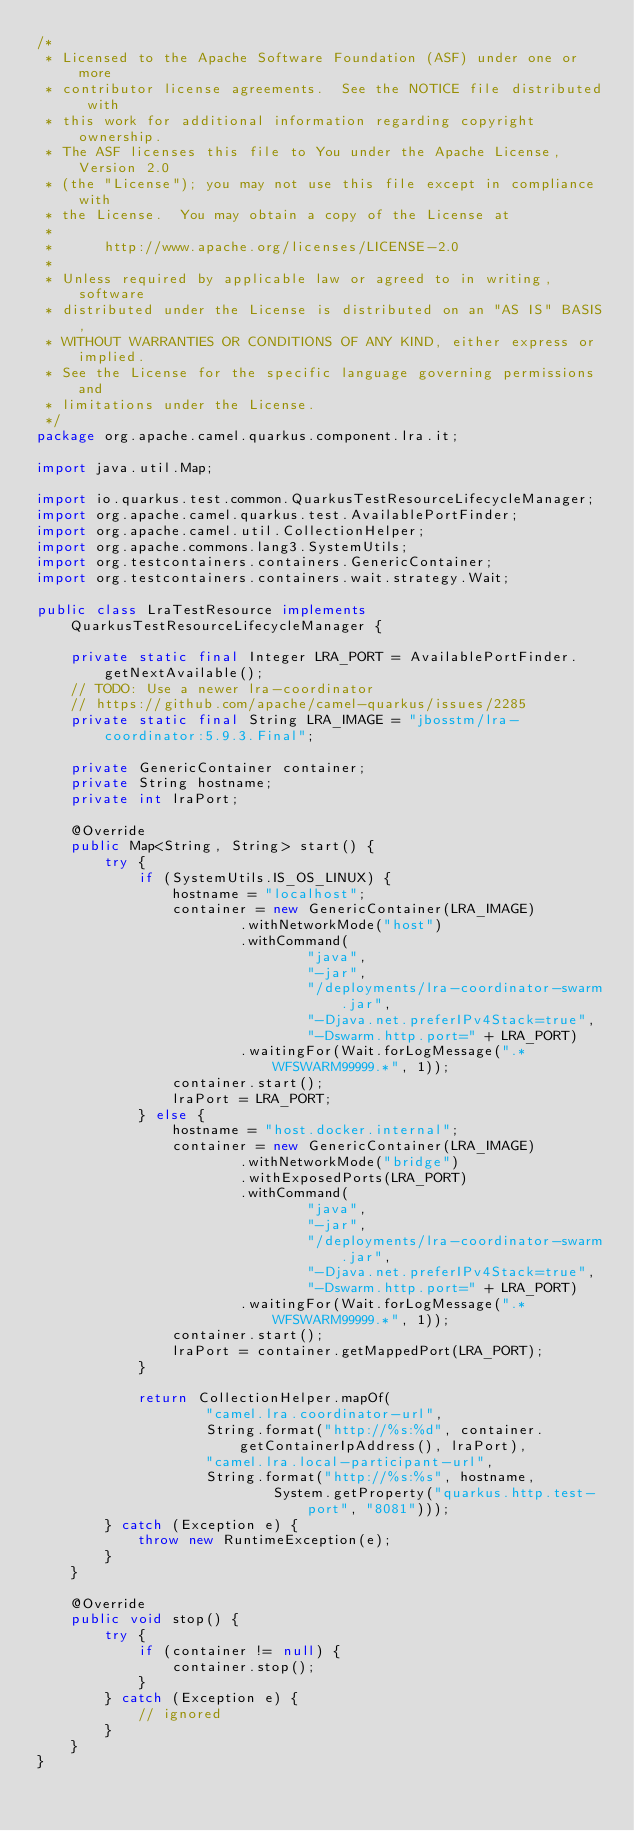Convert code to text. <code><loc_0><loc_0><loc_500><loc_500><_Java_>/*
 * Licensed to the Apache Software Foundation (ASF) under one or more
 * contributor license agreements.  See the NOTICE file distributed with
 * this work for additional information regarding copyright ownership.
 * The ASF licenses this file to You under the Apache License, Version 2.0
 * (the "License"); you may not use this file except in compliance with
 * the License.  You may obtain a copy of the License at
 *
 *      http://www.apache.org/licenses/LICENSE-2.0
 *
 * Unless required by applicable law or agreed to in writing, software
 * distributed under the License is distributed on an "AS IS" BASIS,
 * WITHOUT WARRANTIES OR CONDITIONS OF ANY KIND, either express or implied.
 * See the License for the specific language governing permissions and
 * limitations under the License.
 */
package org.apache.camel.quarkus.component.lra.it;

import java.util.Map;

import io.quarkus.test.common.QuarkusTestResourceLifecycleManager;
import org.apache.camel.quarkus.test.AvailablePortFinder;
import org.apache.camel.util.CollectionHelper;
import org.apache.commons.lang3.SystemUtils;
import org.testcontainers.containers.GenericContainer;
import org.testcontainers.containers.wait.strategy.Wait;

public class LraTestResource implements QuarkusTestResourceLifecycleManager {

    private static final Integer LRA_PORT = AvailablePortFinder.getNextAvailable();
    // TODO: Use a newer lra-coordinator
    // https://github.com/apache/camel-quarkus/issues/2285
    private static final String LRA_IMAGE = "jbosstm/lra-coordinator:5.9.3.Final";

    private GenericContainer container;
    private String hostname;
    private int lraPort;

    @Override
    public Map<String, String> start() {
        try {
            if (SystemUtils.IS_OS_LINUX) {
                hostname = "localhost";
                container = new GenericContainer(LRA_IMAGE)
                        .withNetworkMode("host")
                        .withCommand(
                                "java",
                                "-jar",
                                "/deployments/lra-coordinator-swarm.jar",
                                "-Djava.net.preferIPv4Stack=true",
                                "-Dswarm.http.port=" + LRA_PORT)
                        .waitingFor(Wait.forLogMessage(".*WFSWARM99999.*", 1));
                container.start();
                lraPort = LRA_PORT;
            } else {
                hostname = "host.docker.internal";
                container = new GenericContainer(LRA_IMAGE)
                        .withNetworkMode("bridge")
                        .withExposedPorts(LRA_PORT)
                        .withCommand(
                                "java",
                                "-jar",
                                "/deployments/lra-coordinator-swarm.jar",
                                "-Djava.net.preferIPv4Stack=true",
                                "-Dswarm.http.port=" + LRA_PORT)
                        .waitingFor(Wait.forLogMessage(".*WFSWARM99999.*", 1));
                container.start();
                lraPort = container.getMappedPort(LRA_PORT);
            }

            return CollectionHelper.mapOf(
                    "camel.lra.coordinator-url",
                    String.format("http://%s:%d", container.getContainerIpAddress(), lraPort),
                    "camel.lra.local-participant-url",
                    String.format("http://%s:%s", hostname,
                            System.getProperty("quarkus.http.test-port", "8081")));
        } catch (Exception e) {
            throw new RuntimeException(e);
        }
    }

    @Override
    public void stop() {
        try {
            if (container != null) {
                container.stop();
            }
        } catch (Exception e) {
            // ignored
        }
    }
}
</code> 